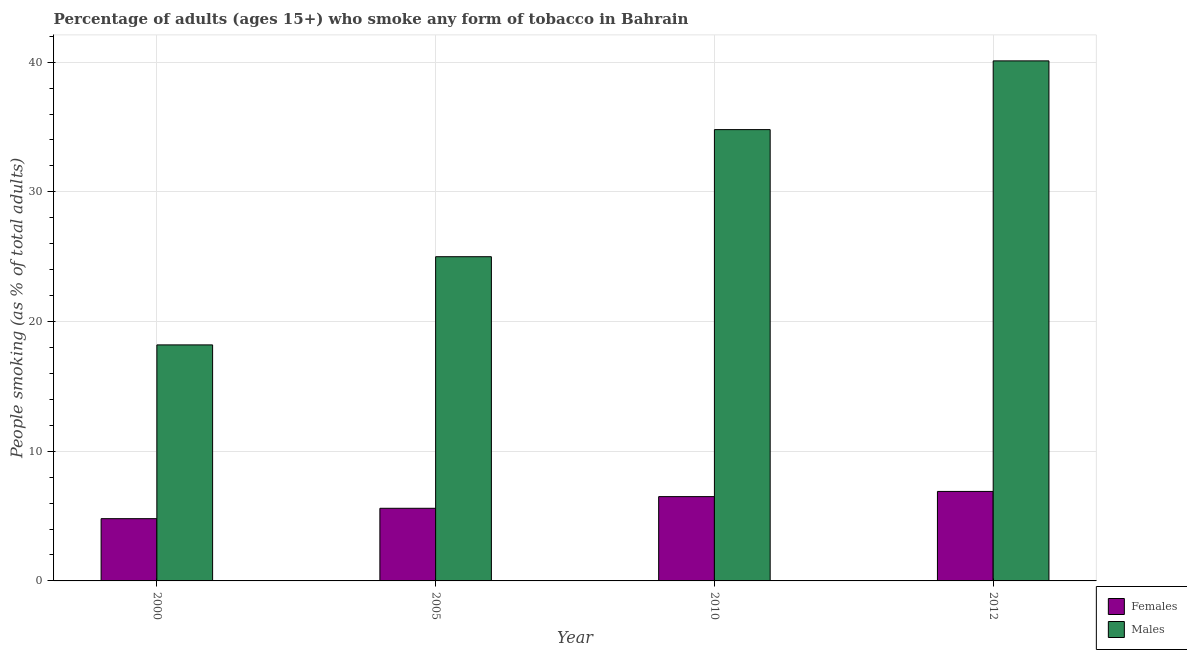How many bars are there on the 4th tick from the right?
Your answer should be very brief. 2. In how many cases, is the number of bars for a given year not equal to the number of legend labels?
Provide a succinct answer. 0. What is the percentage of males who smoke in 2010?
Ensure brevity in your answer.  34.8. In which year was the percentage of males who smoke maximum?
Provide a succinct answer. 2012. In which year was the percentage of females who smoke minimum?
Provide a short and direct response. 2000. What is the total percentage of males who smoke in the graph?
Make the answer very short. 118.1. What is the difference between the percentage of males who smoke in 2010 and that in 2012?
Your answer should be very brief. -5.3. What is the difference between the percentage of females who smoke in 2012 and the percentage of males who smoke in 2000?
Offer a very short reply. 2.1. What is the average percentage of females who smoke per year?
Ensure brevity in your answer.  5.95. In how many years, is the percentage of females who smoke greater than 22 %?
Keep it short and to the point. 0. What is the ratio of the percentage of males who smoke in 2000 to that in 2005?
Your answer should be compact. 0.73. What is the difference between the highest and the second highest percentage of males who smoke?
Offer a terse response. 5.3. What is the difference between the highest and the lowest percentage of females who smoke?
Your response must be concise. 2.1. What does the 1st bar from the left in 2005 represents?
Provide a short and direct response. Females. What does the 1st bar from the right in 2005 represents?
Keep it short and to the point. Males. Are all the bars in the graph horizontal?
Make the answer very short. No. How many years are there in the graph?
Your answer should be very brief. 4. What is the difference between two consecutive major ticks on the Y-axis?
Offer a very short reply. 10. Where does the legend appear in the graph?
Provide a succinct answer. Bottom right. What is the title of the graph?
Offer a very short reply. Percentage of adults (ages 15+) who smoke any form of tobacco in Bahrain. Does "Electricity" appear as one of the legend labels in the graph?
Your answer should be very brief. No. What is the label or title of the X-axis?
Make the answer very short. Year. What is the label or title of the Y-axis?
Keep it short and to the point. People smoking (as % of total adults). What is the People smoking (as % of total adults) of Males in 2000?
Your response must be concise. 18.2. What is the People smoking (as % of total adults) in Males in 2010?
Your answer should be compact. 34.8. What is the People smoking (as % of total adults) in Males in 2012?
Give a very brief answer. 40.1. Across all years, what is the maximum People smoking (as % of total adults) of Females?
Your answer should be compact. 6.9. Across all years, what is the maximum People smoking (as % of total adults) of Males?
Make the answer very short. 40.1. What is the total People smoking (as % of total adults) in Females in the graph?
Give a very brief answer. 23.8. What is the total People smoking (as % of total adults) of Males in the graph?
Your answer should be very brief. 118.1. What is the difference between the People smoking (as % of total adults) in Females in 2000 and that in 2005?
Provide a short and direct response. -0.8. What is the difference between the People smoking (as % of total adults) of Males in 2000 and that in 2010?
Keep it short and to the point. -16.6. What is the difference between the People smoking (as % of total adults) in Females in 2000 and that in 2012?
Your answer should be compact. -2.1. What is the difference between the People smoking (as % of total adults) in Males in 2000 and that in 2012?
Provide a succinct answer. -21.9. What is the difference between the People smoking (as % of total adults) of Males in 2005 and that in 2012?
Provide a succinct answer. -15.1. What is the difference between the People smoking (as % of total adults) of Females in 2010 and that in 2012?
Keep it short and to the point. -0.4. What is the difference between the People smoking (as % of total adults) of Females in 2000 and the People smoking (as % of total adults) of Males in 2005?
Ensure brevity in your answer.  -20.2. What is the difference between the People smoking (as % of total adults) in Females in 2000 and the People smoking (as % of total adults) in Males in 2010?
Offer a very short reply. -30. What is the difference between the People smoking (as % of total adults) of Females in 2000 and the People smoking (as % of total adults) of Males in 2012?
Offer a terse response. -35.3. What is the difference between the People smoking (as % of total adults) in Females in 2005 and the People smoking (as % of total adults) in Males in 2010?
Your answer should be compact. -29.2. What is the difference between the People smoking (as % of total adults) in Females in 2005 and the People smoking (as % of total adults) in Males in 2012?
Give a very brief answer. -34.5. What is the difference between the People smoking (as % of total adults) of Females in 2010 and the People smoking (as % of total adults) of Males in 2012?
Your response must be concise. -33.6. What is the average People smoking (as % of total adults) in Females per year?
Make the answer very short. 5.95. What is the average People smoking (as % of total adults) in Males per year?
Offer a very short reply. 29.52. In the year 2005, what is the difference between the People smoking (as % of total adults) in Females and People smoking (as % of total adults) in Males?
Provide a succinct answer. -19.4. In the year 2010, what is the difference between the People smoking (as % of total adults) in Females and People smoking (as % of total adults) in Males?
Make the answer very short. -28.3. In the year 2012, what is the difference between the People smoking (as % of total adults) of Females and People smoking (as % of total adults) of Males?
Your response must be concise. -33.2. What is the ratio of the People smoking (as % of total adults) of Males in 2000 to that in 2005?
Give a very brief answer. 0.73. What is the ratio of the People smoking (as % of total adults) of Females in 2000 to that in 2010?
Offer a very short reply. 0.74. What is the ratio of the People smoking (as % of total adults) in Males in 2000 to that in 2010?
Offer a very short reply. 0.52. What is the ratio of the People smoking (as % of total adults) of Females in 2000 to that in 2012?
Offer a very short reply. 0.7. What is the ratio of the People smoking (as % of total adults) of Males in 2000 to that in 2012?
Keep it short and to the point. 0.45. What is the ratio of the People smoking (as % of total adults) of Females in 2005 to that in 2010?
Provide a succinct answer. 0.86. What is the ratio of the People smoking (as % of total adults) in Males in 2005 to that in 2010?
Give a very brief answer. 0.72. What is the ratio of the People smoking (as % of total adults) in Females in 2005 to that in 2012?
Your answer should be very brief. 0.81. What is the ratio of the People smoking (as % of total adults) of Males in 2005 to that in 2012?
Make the answer very short. 0.62. What is the ratio of the People smoking (as % of total adults) of Females in 2010 to that in 2012?
Provide a succinct answer. 0.94. What is the ratio of the People smoking (as % of total adults) of Males in 2010 to that in 2012?
Keep it short and to the point. 0.87. What is the difference between the highest and the second highest People smoking (as % of total adults) of Females?
Your response must be concise. 0.4. What is the difference between the highest and the lowest People smoking (as % of total adults) in Males?
Ensure brevity in your answer.  21.9. 